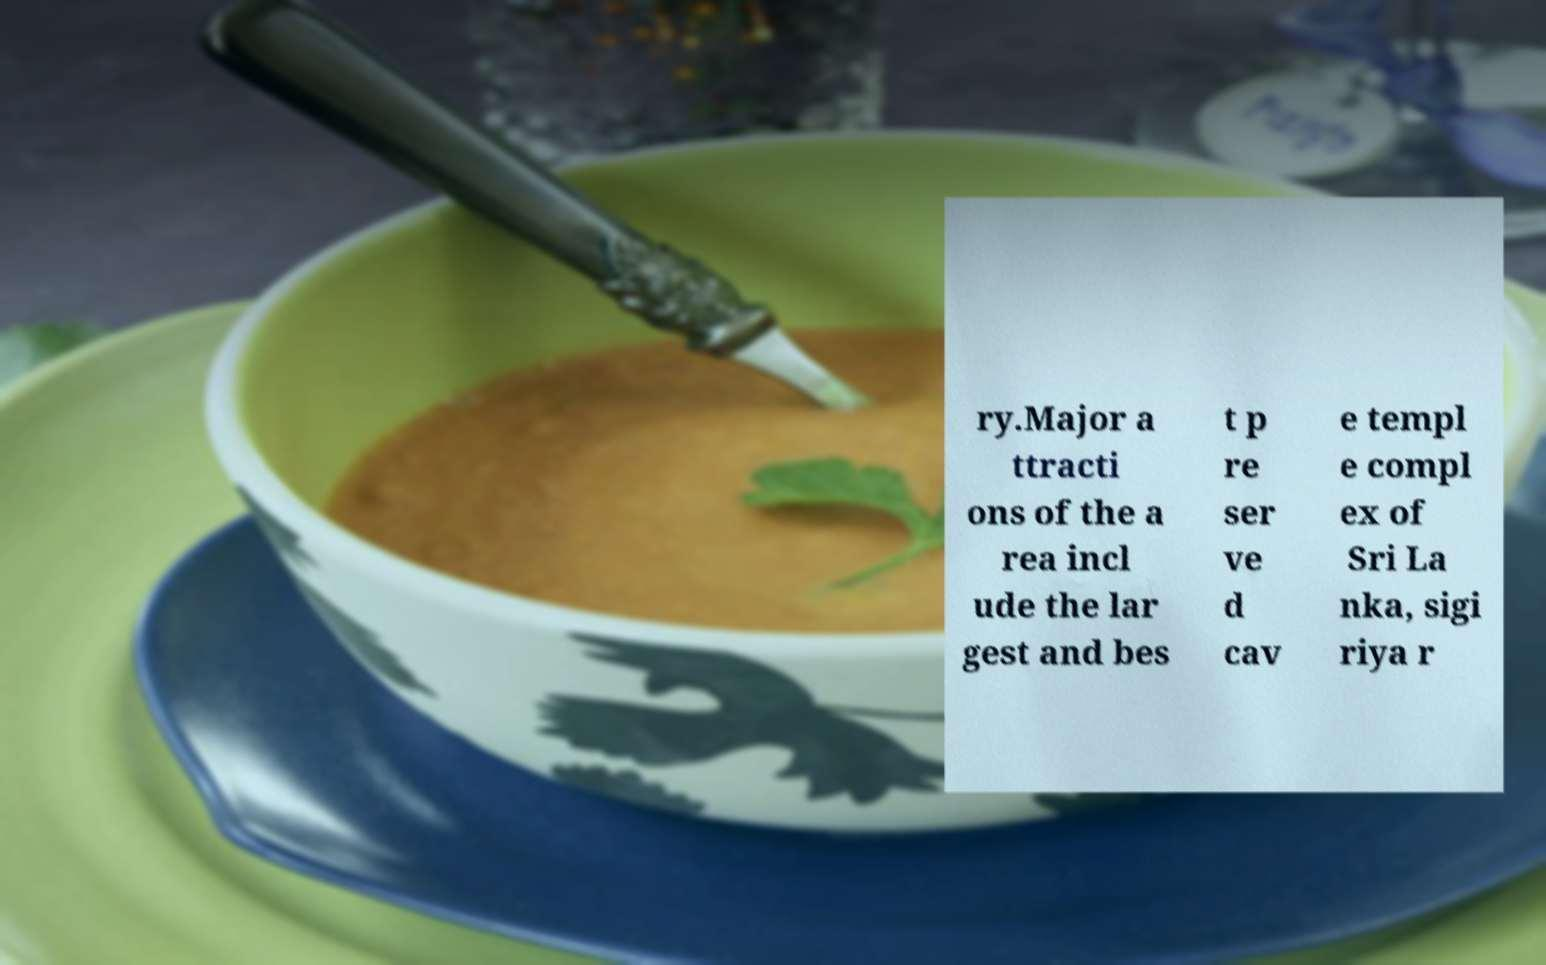I need the written content from this picture converted into text. Can you do that? ry.Major a ttracti ons of the a rea incl ude the lar gest and bes t p re ser ve d cav e templ e compl ex of Sri La nka, sigi riya r 